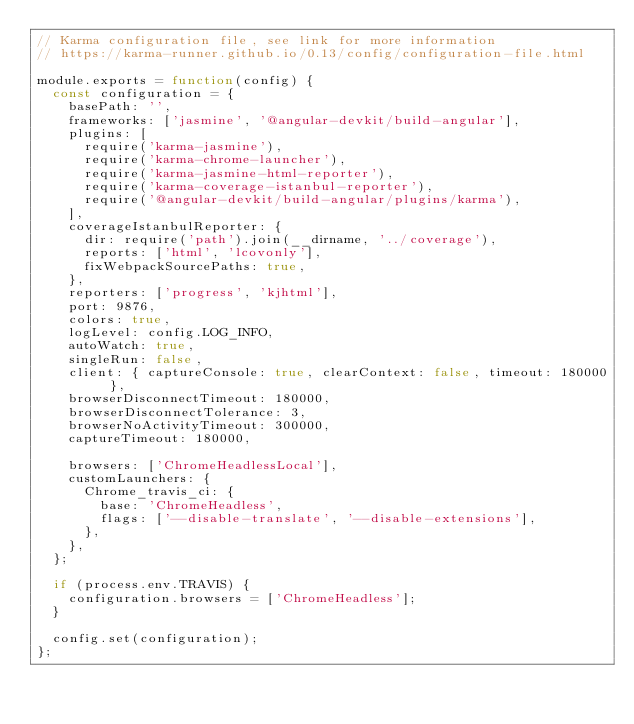<code> <loc_0><loc_0><loc_500><loc_500><_JavaScript_>// Karma configuration file, see link for more information
// https://karma-runner.github.io/0.13/config/configuration-file.html

module.exports = function(config) {
  const configuration = {
    basePath: '',
    frameworks: ['jasmine', '@angular-devkit/build-angular'],
    plugins: [
      require('karma-jasmine'),
      require('karma-chrome-launcher'),
      require('karma-jasmine-html-reporter'),
      require('karma-coverage-istanbul-reporter'),
      require('@angular-devkit/build-angular/plugins/karma'),
    ],
    coverageIstanbulReporter: {
      dir: require('path').join(__dirname, '../coverage'),
      reports: ['html', 'lcovonly'],
      fixWebpackSourcePaths: true,
    },
    reporters: ['progress', 'kjhtml'],
    port: 9876,
    colors: true,
    logLevel: config.LOG_INFO,
    autoWatch: true,
    singleRun: false,
    client: { captureConsole: true, clearContext: false, timeout: 180000 },
    browserDisconnectTimeout: 180000,
    browserDisconnectTolerance: 3,
    browserNoActivityTimeout: 300000,
    captureTimeout: 180000,

    browsers: ['ChromeHeadlessLocal'],
    customLaunchers: {
      Chrome_travis_ci: {
        base: 'ChromeHeadless',
        flags: ['--disable-translate', '--disable-extensions'],
      },
    },
  };

  if (process.env.TRAVIS) {
    configuration.browsers = ['ChromeHeadless'];
  }

  config.set(configuration);
};
</code> 